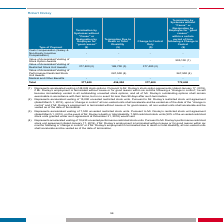From Systemax's financial document, What are the accelerated vesting of Robert Dooley's unvested restricted stock units for change in control only or termination due to death respectively?  The document shows two values: 15,000 and 7,500. From the document: "267,500 (4) 267,500 (4) (2) Represents accelerated vesting of 15,000 unvested restricted stock units. Pursuant to Mr. Dooley’s restricted stock unit a..." Also, What are the accelerated vesting of Robert Dooley's stock options for termination by Systemax without "Cause" or unvested performance restricted stock units for termination due to death respectively? The document shows two values: 48,849 and 10,630. From the document: "(1) Represents accelerated vesting of 48,849 stock options. Pursuant to Mr. Dooley’s stock option agreements (dated January 17, 2019), (4) Represents ..." Also, What is Robert Dooley's total payment due to change in control only? According to the financial document, 377,400. The relevant text states: "celerated Vesting of Restricted Stock Unit Awards 377,400 (2) 188,700 (3) 377,400 (2) -..." Also, can you calculate: What are the accelerated vesting of Robert Dooley's unvested restricted stock units for termination by Systemax without "cause" or termination due to death?  Based on the calculation: 15,000 + 7,500 , the result is 22500. This is based on the information: "267,500 (4) 267,500 (4) (2) Represents accelerated vesting of 15,000 unvested restricted stock units. Pursuant to Mr. Dooley’s restricted stock unit agreement 267,500 (4) 267,500 (4) 267,500 (4) 267,5..." The key data points involved are: 15,000, 7,500. Also, can you calculate: What is the total accelerated vesting of Robert Dooley's stock options and unvested performance restricted stock units? Based on the calculation: 48,849 + 10,630 , the result is 59479. This is based on the information: "(1) Represents accelerated vesting of 48,849 stock options. Pursuant to Mr. Dooley’s stock option agreements (dated January 17, 2019), (4) Represents accelerated vesting of 10,630 unvested performance..." The key data points involved are: 10,630, 48,849. Also, can you calculate: What is the percentage of payment due as a result of change in control as a percentage of the payment due to termination without cause within a certain period following a change in control? Based on the calculation: 377,400/772,600 , the result is 48.85 (percentage). This is based on the information: "Total 377,400 456,200 377,400 772,600 Total 377,400 456,200 377,400 772,600..." The key data points involved are: 377,400, 772,600. 